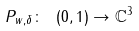Convert formula to latex. <formula><loc_0><loc_0><loc_500><loc_500>P _ { w , \delta } \colon \ ( 0 , 1 ) \to \mathbb { C } ^ { 3 }</formula> 